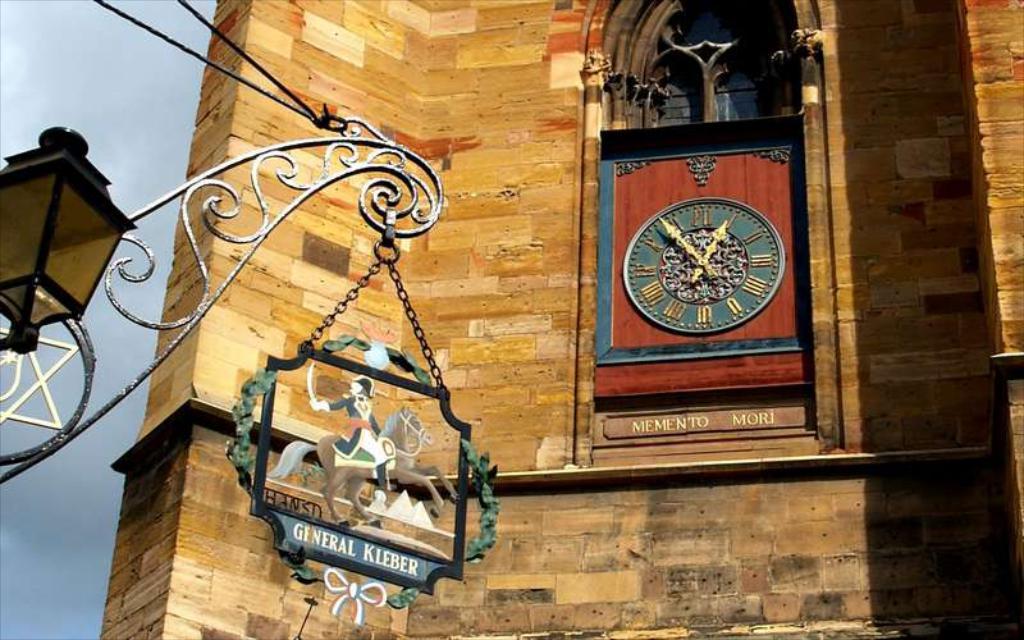What is written below the clock?
Provide a succinct answer. Memento mori. 